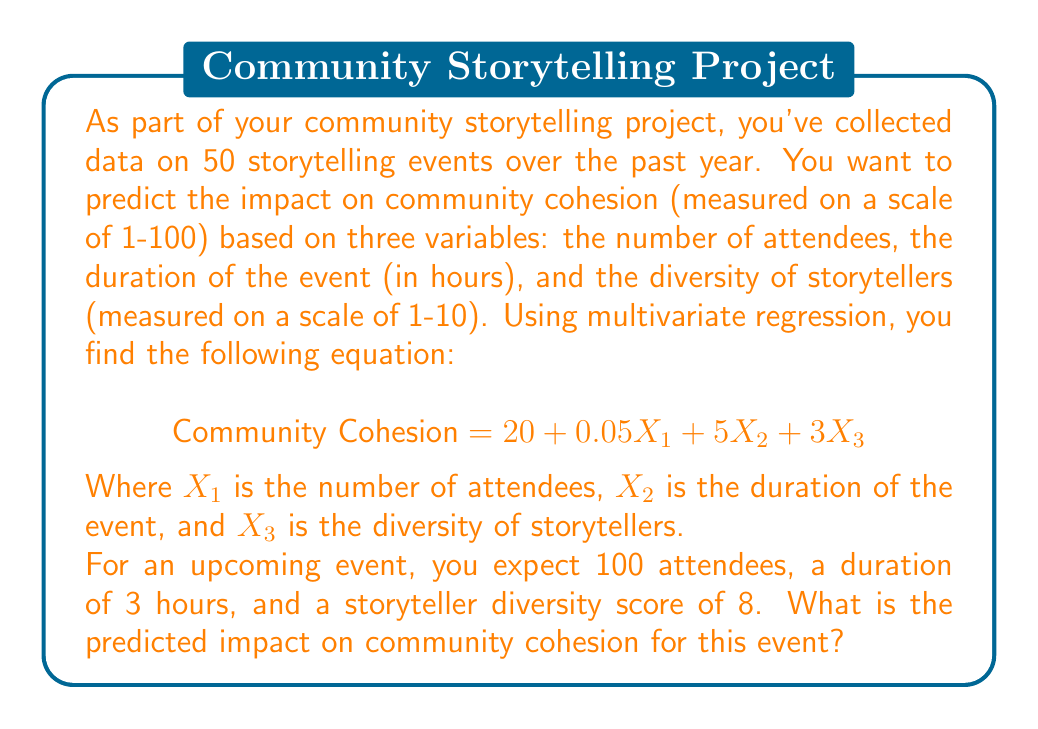Help me with this question. To solve this problem, we need to use the given multivariate regression equation and substitute the values for our upcoming event. Let's break it down step-by-step:

1. Recall the equation:
   $$ \text{Community Cohesion} = 20 + 0.05X_1 + 5X_2 + 3X_3 $$

2. We have the following values for our variables:
   $X_1$ (number of attendees) = 100
   $X_2$ (duration of the event) = 3 hours
   $X_3$ (diversity of storytellers) = 8

3. Let's substitute these values into our equation:
   $$ \text{Community Cohesion} = 20 + 0.05(100) + 5(3) + 3(8) $$

4. Now, let's solve each term:
   - $20$ remains as is
   - $0.05(100) = 5$
   - $5(3) = 15$
   - $3(8) = 24$

5. Add all the terms together:
   $$ \text{Community Cohesion} = 20 + 5 + 15 + 24 = 64 $$

Therefore, the predicted impact on community cohesion for this event is 64 on a scale of 1-100.
Answer: 64 